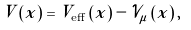Convert formula to latex. <formula><loc_0><loc_0><loc_500><loc_500>V \left ( x \right ) = V _ { \text {eff} } \left ( x \right ) - \mathcal { V } _ { \mu } \left ( x \right ) ,</formula> 